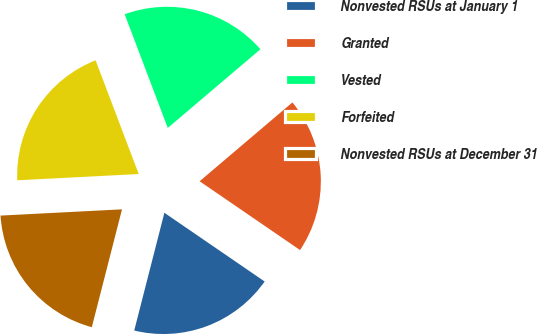Convert chart to OTSL. <chart><loc_0><loc_0><loc_500><loc_500><pie_chart><fcel>Nonvested RSUs at January 1<fcel>Granted<fcel>Vested<fcel>Forfeited<fcel>Nonvested RSUs at December 31<nl><fcel>19.43%<fcel>20.77%<fcel>19.56%<fcel>20.05%<fcel>20.19%<nl></chart> 